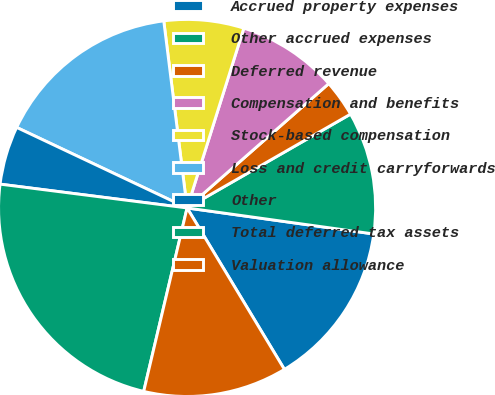Convert chart to OTSL. <chart><loc_0><loc_0><loc_500><loc_500><pie_chart><fcel>Accrued property expenses<fcel>Other accrued expenses<fcel>Deferred revenue<fcel>Compensation and benefits<fcel>Stock-based compensation<fcel>Loss and credit carryforwards<fcel>Other<fcel>Total deferred tax assets<fcel>Valuation allowance<nl><fcel>14.16%<fcel>10.5%<fcel>3.17%<fcel>8.67%<fcel>6.84%<fcel>16.0%<fcel>5.01%<fcel>23.32%<fcel>12.33%<nl></chart> 